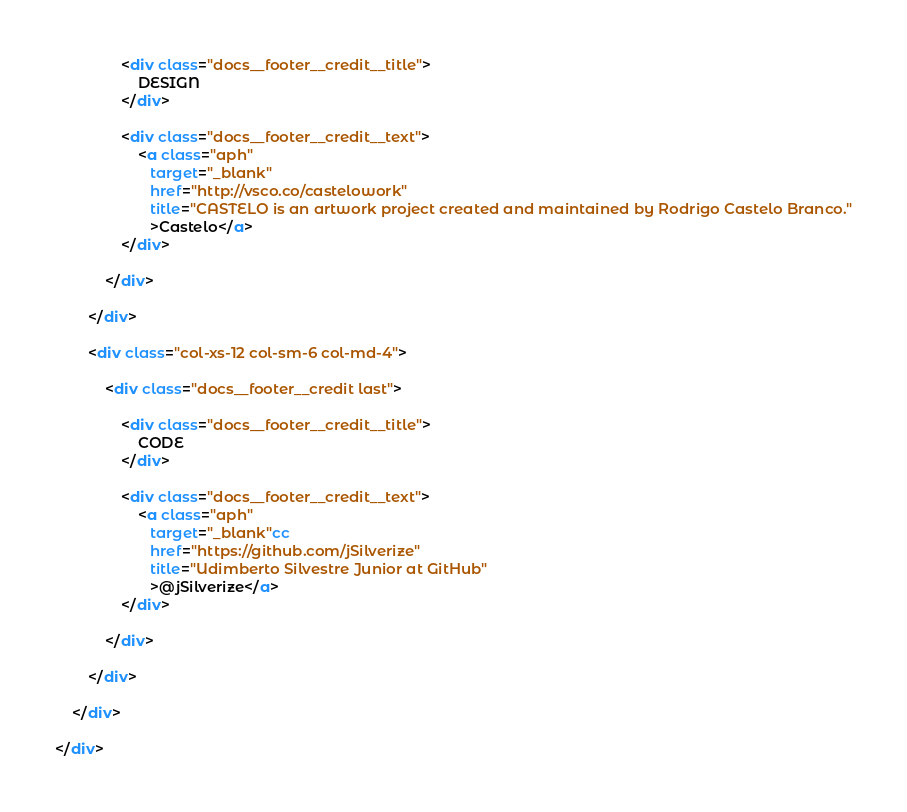<code> <loc_0><loc_0><loc_500><loc_500><_HTML_>                <div class="docs__footer__credit__title">
                    DESIGN
                </div>

                <div class="docs__footer__credit__text">
                    <a class="aph"
                       target="_blank"
                       href="http://vsco.co/castelowork"
                       title="CASTELO is an artwork project created and maintained by Rodrigo Castelo Branco."
                       >Castelo</a>
                </div>

            </div>

        </div>

        <div class="col-xs-12 col-sm-6 col-md-4">

            <div class="docs__footer__credit last">

                <div class="docs__footer__credit__title">
                    CODE
                </div>

                <div class="docs__footer__credit__text">
                    <a class="aph"
                       target="_blank"cc
                       href="https://github.com/jSilverize"
                       title="Udimberto Silvestre Junior at GitHub"
                       >@jSilverize</a>
                </div>

            </div>

        </div>

    </div>

</div>
</code> 